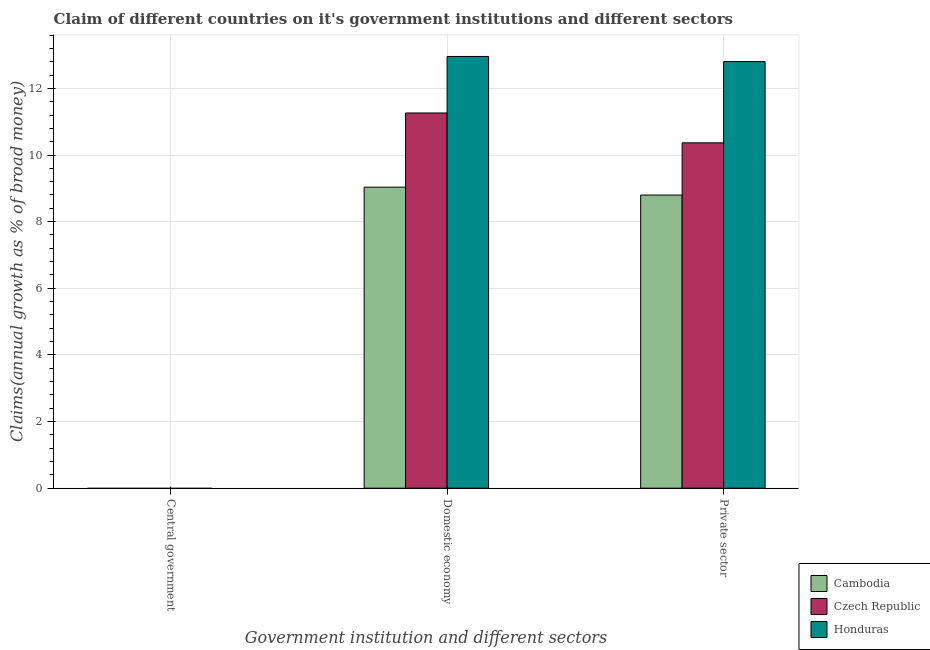Are the number of bars per tick equal to the number of legend labels?
Ensure brevity in your answer.  No. How many bars are there on the 1st tick from the left?
Your answer should be compact. 0. How many bars are there on the 2nd tick from the right?
Keep it short and to the point. 3. What is the label of the 1st group of bars from the left?
Your response must be concise. Central government. What is the percentage of claim on the domestic economy in Cambodia?
Make the answer very short. 9.03. Across all countries, what is the maximum percentage of claim on the private sector?
Your answer should be very brief. 12.8. In which country was the percentage of claim on the domestic economy maximum?
Your answer should be compact. Honduras. What is the total percentage of claim on the central government in the graph?
Your response must be concise. 0. What is the difference between the percentage of claim on the private sector in Cambodia and that in Honduras?
Keep it short and to the point. -4.01. What is the difference between the percentage of claim on the central government in Cambodia and the percentage of claim on the private sector in Honduras?
Your response must be concise. -12.8. What is the average percentage of claim on the private sector per country?
Offer a very short reply. 10.66. What is the difference between the percentage of claim on the domestic economy and percentage of claim on the private sector in Czech Republic?
Ensure brevity in your answer.  0.9. What is the ratio of the percentage of claim on the domestic economy in Cambodia to that in Honduras?
Ensure brevity in your answer.  0.7. What is the difference between the highest and the second highest percentage of claim on the private sector?
Your answer should be very brief. 2.44. What is the difference between the highest and the lowest percentage of claim on the domestic economy?
Ensure brevity in your answer.  3.92. Is the sum of the percentage of claim on the domestic economy in Honduras and Czech Republic greater than the maximum percentage of claim on the central government across all countries?
Ensure brevity in your answer.  Yes. Is it the case that in every country, the sum of the percentage of claim on the central government and percentage of claim on the domestic economy is greater than the percentage of claim on the private sector?
Provide a short and direct response. Yes. Are all the bars in the graph horizontal?
Make the answer very short. No. How many countries are there in the graph?
Offer a terse response. 3. What is the difference between two consecutive major ticks on the Y-axis?
Your response must be concise. 2. Are the values on the major ticks of Y-axis written in scientific E-notation?
Your response must be concise. No. Does the graph contain grids?
Your answer should be very brief. Yes. Where does the legend appear in the graph?
Give a very brief answer. Bottom right. How many legend labels are there?
Provide a short and direct response. 3. What is the title of the graph?
Your response must be concise. Claim of different countries on it's government institutions and different sectors. What is the label or title of the X-axis?
Your answer should be very brief. Government institution and different sectors. What is the label or title of the Y-axis?
Ensure brevity in your answer.  Claims(annual growth as % of broad money). What is the Claims(annual growth as % of broad money) of Cambodia in Central government?
Offer a very short reply. 0. What is the Claims(annual growth as % of broad money) in Czech Republic in Central government?
Your answer should be very brief. 0. What is the Claims(annual growth as % of broad money) in Honduras in Central government?
Give a very brief answer. 0. What is the Claims(annual growth as % of broad money) in Cambodia in Domestic economy?
Your answer should be very brief. 9.03. What is the Claims(annual growth as % of broad money) in Czech Republic in Domestic economy?
Your answer should be compact. 11.26. What is the Claims(annual growth as % of broad money) of Honduras in Domestic economy?
Provide a succinct answer. 12.96. What is the Claims(annual growth as % of broad money) of Cambodia in Private sector?
Make the answer very short. 8.8. What is the Claims(annual growth as % of broad money) of Czech Republic in Private sector?
Offer a very short reply. 10.37. What is the Claims(annual growth as % of broad money) of Honduras in Private sector?
Give a very brief answer. 12.8. Across all Government institution and different sectors, what is the maximum Claims(annual growth as % of broad money) of Cambodia?
Your response must be concise. 9.03. Across all Government institution and different sectors, what is the maximum Claims(annual growth as % of broad money) in Czech Republic?
Offer a very short reply. 11.26. Across all Government institution and different sectors, what is the maximum Claims(annual growth as % of broad money) in Honduras?
Make the answer very short. 12.96. Across all Government institution and different sectors, what is the minimum Claims(annual growth as % of broad money) of Cambodia?
Give a very brief answer. 0. Across all Government institution and different sectors, what is the minimum Claims(annual growth as % of broad money) of Czech Republic?
Your answer should be compact. 0. What is the total Claims(annual growth as % of broad money) in Cambodia in the graph?
Ensure brevity in your answer.  17.83. What is the total Claims(annual growth as % of broad money) of Czech Republic in the graph?
Your response must be concise. 21.63. What is the total Claims(annual growth as % of broad money) of Honduras in the graph?
Your answer should be compact. 25.76. What is the difference between the Claims(annual growth as % of broad money) in Cambodia in Domestic economy and that in Private sector?
Make the answer very short. 0.24. What is the difference between the Claims(annual growth as % of broad money) of Czech Republic in Domestic economy and that in Private sector?
Keep it short and to the point. 0.9. What is the difference between the Claims(annual growth as % of broad money) in Honduras in Domestic economy and that in Private sector?
Offer a terse response. 0.15. What is the difference between the Claims(annual growth as % of broad money) in Cambodia in Domestic economy and the Claims(annual growth as % of broad money) in Czech Republic in Private sector?
Offer a terse response. -1.33. What is the difference between the Claims(annual growth as % of broad money) in Cambodia in Domestic economy and the Claims(annual growth as % of broad money) in Honduras in Private sector?
Ensure brevity in your answer.  -3.77. What is the difference between the Claims(annual growth as % of broad money) of Czech Republic in Domestic economy and the Claims(annual growth as % of broad money) of Honduras in Private sector?
Your answer should be compact. -1.54. What is the average Claims(annual growth as % of broad money) in Cambodia per Government institution and different sectors?
Provide a short and direct response. 5.94. What is the average Claims(annual growth as % of broad money) in Czech Republic per Government institution and different sectors?
Offer a terse response. 7.21. What is the average Claims(annual growth as % of broad money) in Honduras per Government institution and different sectors?
Keep it short and to the point. 8.59. What is the difference between the Claims(annual growth as % of broad money) in Cambodia and Claims(annual growth as % of broad money) in Czech Republic in Domestic economy?
Offer a very short reply. -2.23. What is the difference between the Claims(annual growth as % of broad money) in Cambodia and Claims(annual growth as % of broad money) in Honduras in Domestic economy?
Offer a terse response. -3.92. What is the difference between the Claims(annual growth as % of broad money) of Czech Republic and Claims(annual growth as % of broad money) of Honduras in Domestic economy?
Offer a terse response. -1.7. What is the difference between the Claims(annual growth as % of broad money) in Cambodia and Claims(annual growth as % of broad money) in Czech Republic in Private sector?
Provide a short and direct response. -1.57. What is the difference between the Claims(annual growth as % of broad money) in Cambodia and Claims(annual growth as % of broad money) in Honduras in Private sector?
Your answer should be very brief. -4.01. What is the difference between the Claims(annual growth as % of broad money) of Czech Republic and Claims(annual growth as % of broad money) of Honduras in Private sector?
Give a very brief answer. -2.44. What is the ratio of the Claims(annual growth as % of broad money) of Cambodia in Domestic economy to that in Private sector?
Your answer should be very brief. 1.03. What is the ratio of the Claims(annual growth as % of broad money) in Czech Republic in Domestic economy to that in Private sector?
Give a very brief answer. 1.09. What is the difference between the highest and the lowest Claims(annual growth as % of broad money) of Cambodia?
Your response must be concise. 9.03. What is the difference between the highest and the lowest Claims(annual growth as % of broad money) of Czech Republic?
Your response must be concise. 11.26. What is the difference between the highest and the lowest Claims(annual growth as % of broad money) in Honduras?
Ensure brevity in your answer.  12.96. 